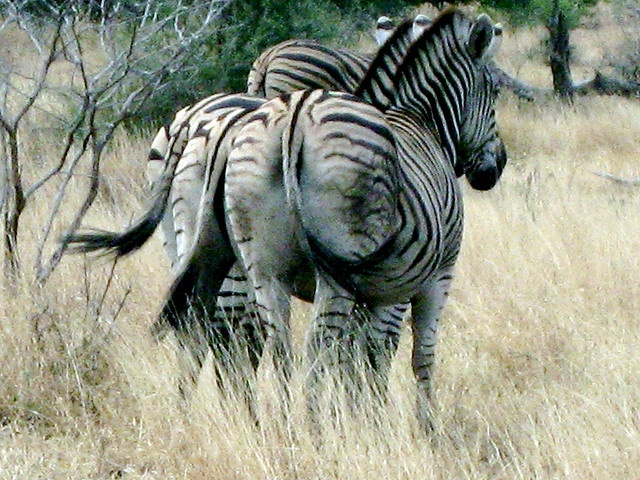Describe the objects in this image and their specific colors. I can see zebra in gray, black, darkgray, and lightgray tones, zebra in gray, black, darkgray, and lightgray tones, zebra in gray, darkgray, lightgray, and black tones, and zebra in gray, darkgray, black, and purple tones in this image. 